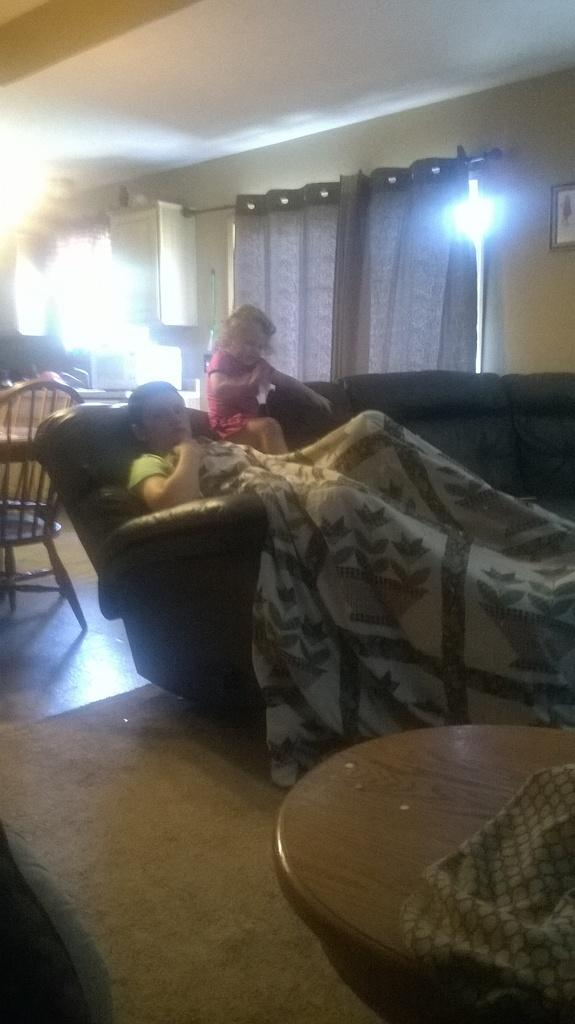Who are the people in the image? There is a boy and a girl in the image. What are they doing in the image? The boy and girl are sitting on a couch. Are there any other furniture pieces in the image? Yes, there is a chair and a table on the floor in the image. What type of lead can be seen in the hands of the boy in the image? There is no lead present in the image, and the boy is not holding anything in his hands. Who is the judge in the image? There is no judge present in the image, as it features a boy and a girl sitting on a couch. 